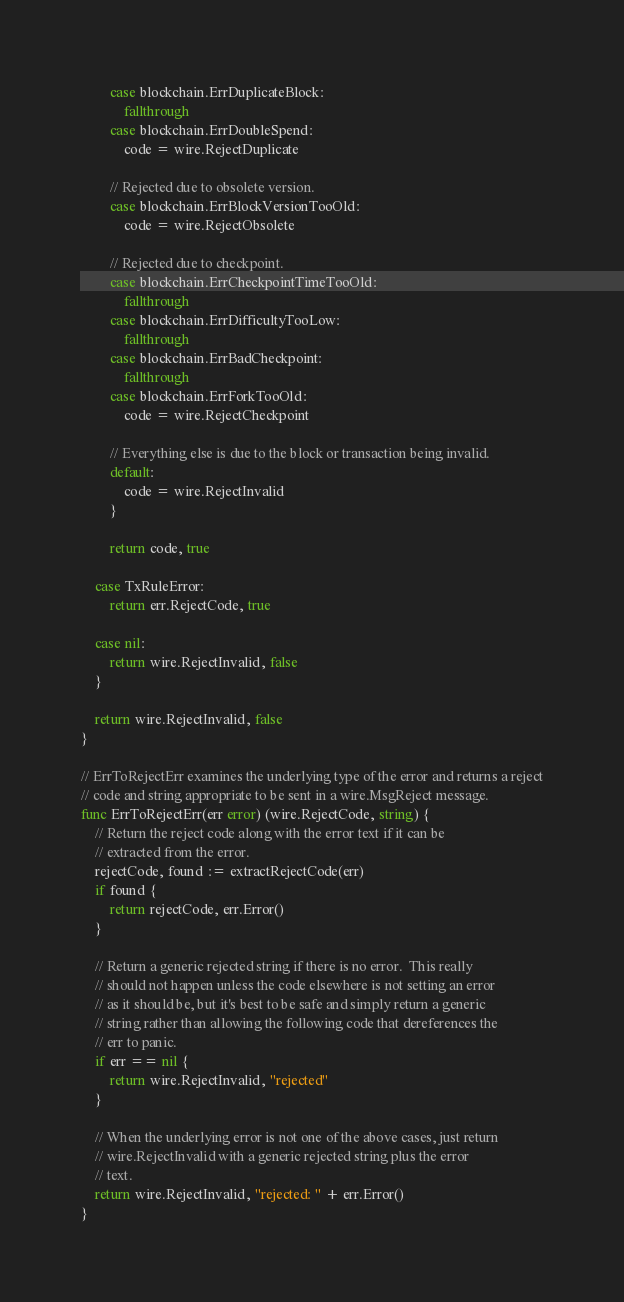<code> <loc_0><loc_0><loc_500><loc_500><_Go_>		case blockchain.ErrDuplicateBlock:
			fallthrough
		case blockchain.ErrDoubleSpend:
			code = wire.RejectDuplicate

		// Rejected due to obsolete version.
		case blockchain.ErrBlockVersionTooOld:
			code = wire.RejectObsolete

		// Rejected due to checkpoint.
		case blockchain.ErrCheckpointTimeTooOld:
			fallthrough
		case blockchain.ErrDifficultyTooLow:
			fallthrough
		case blockchain.ErrBadCheckpoint:
			fallthrough
		case blockchain.ErrForkTooOld:
			code = wire.RejectCheckpoint

		// Everything else is due to the block or transaction being invalid.
		default:
			code = wire.RejectInvalid
		}

		return code, true

	case TxRuleError:
		return err.RejectCode, true

	case nil:
		return wire.RejectInvalid, false
	}

	return wire.RejectInvalid, false
}

// ErrToRejectErr examines the underlying type of the error and returns a reject
// code and string appropriate to be sent in a wire.MsgReject message.
func ErrToRejectErr(err error) (wire.RejectCode, string) {
	// Return the reject code along with the error text if it can be
	// extracted from the error.
	rejectCode, found := extractRejectCode(err)
	if found {
		return rejectCode, err.Error()
	}

	// Return a generic rejected string if there is no error.  This really
	// should not happen unless the code elsewhere is not setting an error
	// as it should be, but it's best to be safe and simply return a generic
	// string rather than allowing the following code that dereferences the
	// err to panic.
	if err == nil {
		return wire.RejectInvalid, "rejected"
	}

	// When the underlying error is not one of the above cases, just return
	// wire.RejectInvalid with a generic rejected string plus the error
	// text.
	return wire.RejectInvalid, "rejected: " + err.Error()
}
</code> 